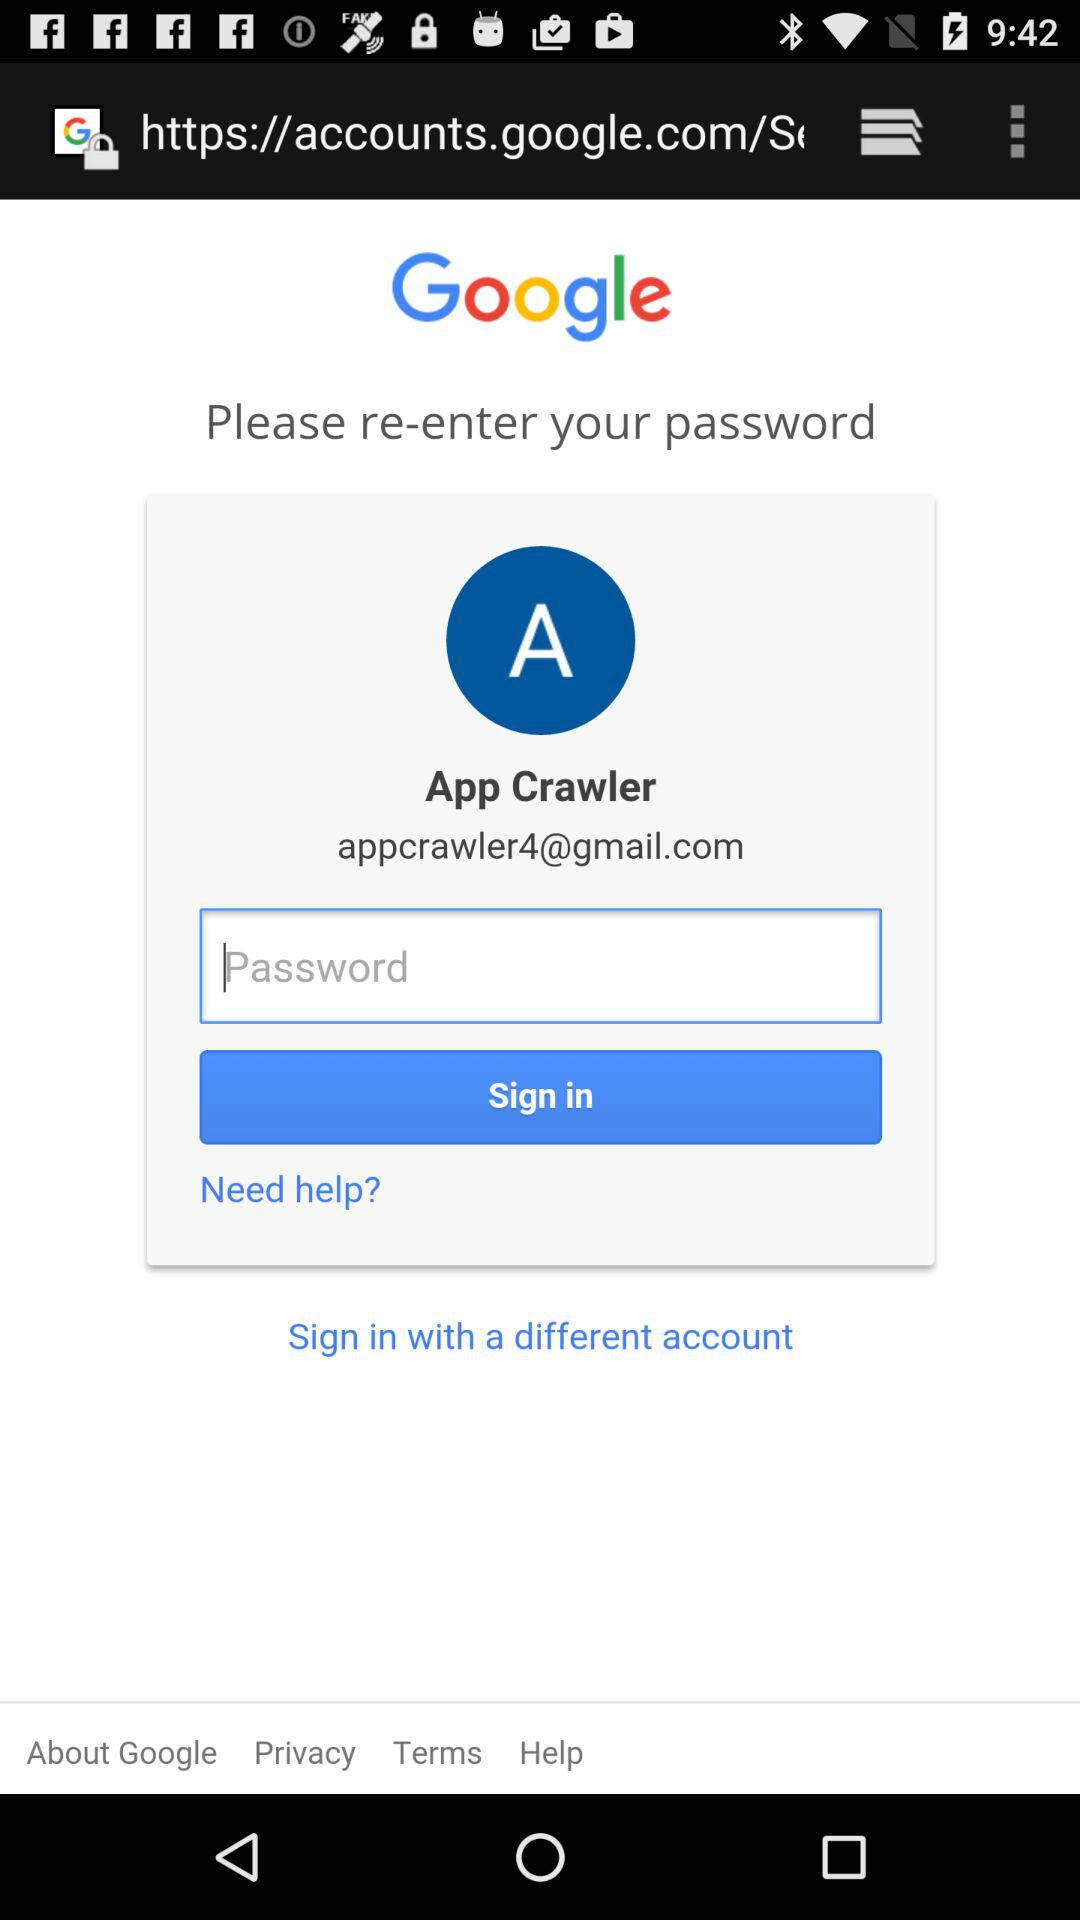What is the user name? The user name is App Crawler. 